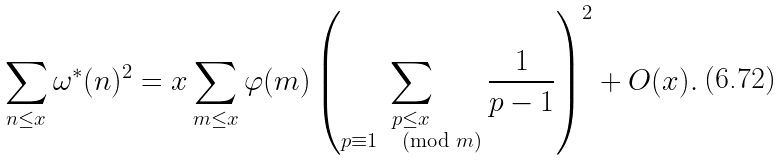<formula> <loc_0><loc_0><loc_500><loc_500>\sum _ { n \leq x } \omega ^ { * } ( n ) ^ { 2 } = x \sum _ { m \leq x } \varphi ( m ) \left ( \sum _ { \substack { p \leq x \\ p \equiv 1 \, \pmod { m } } } \frac { 1 } { p - 1 } \right ) ^ { 2 } + O ( x ) .</formula> 